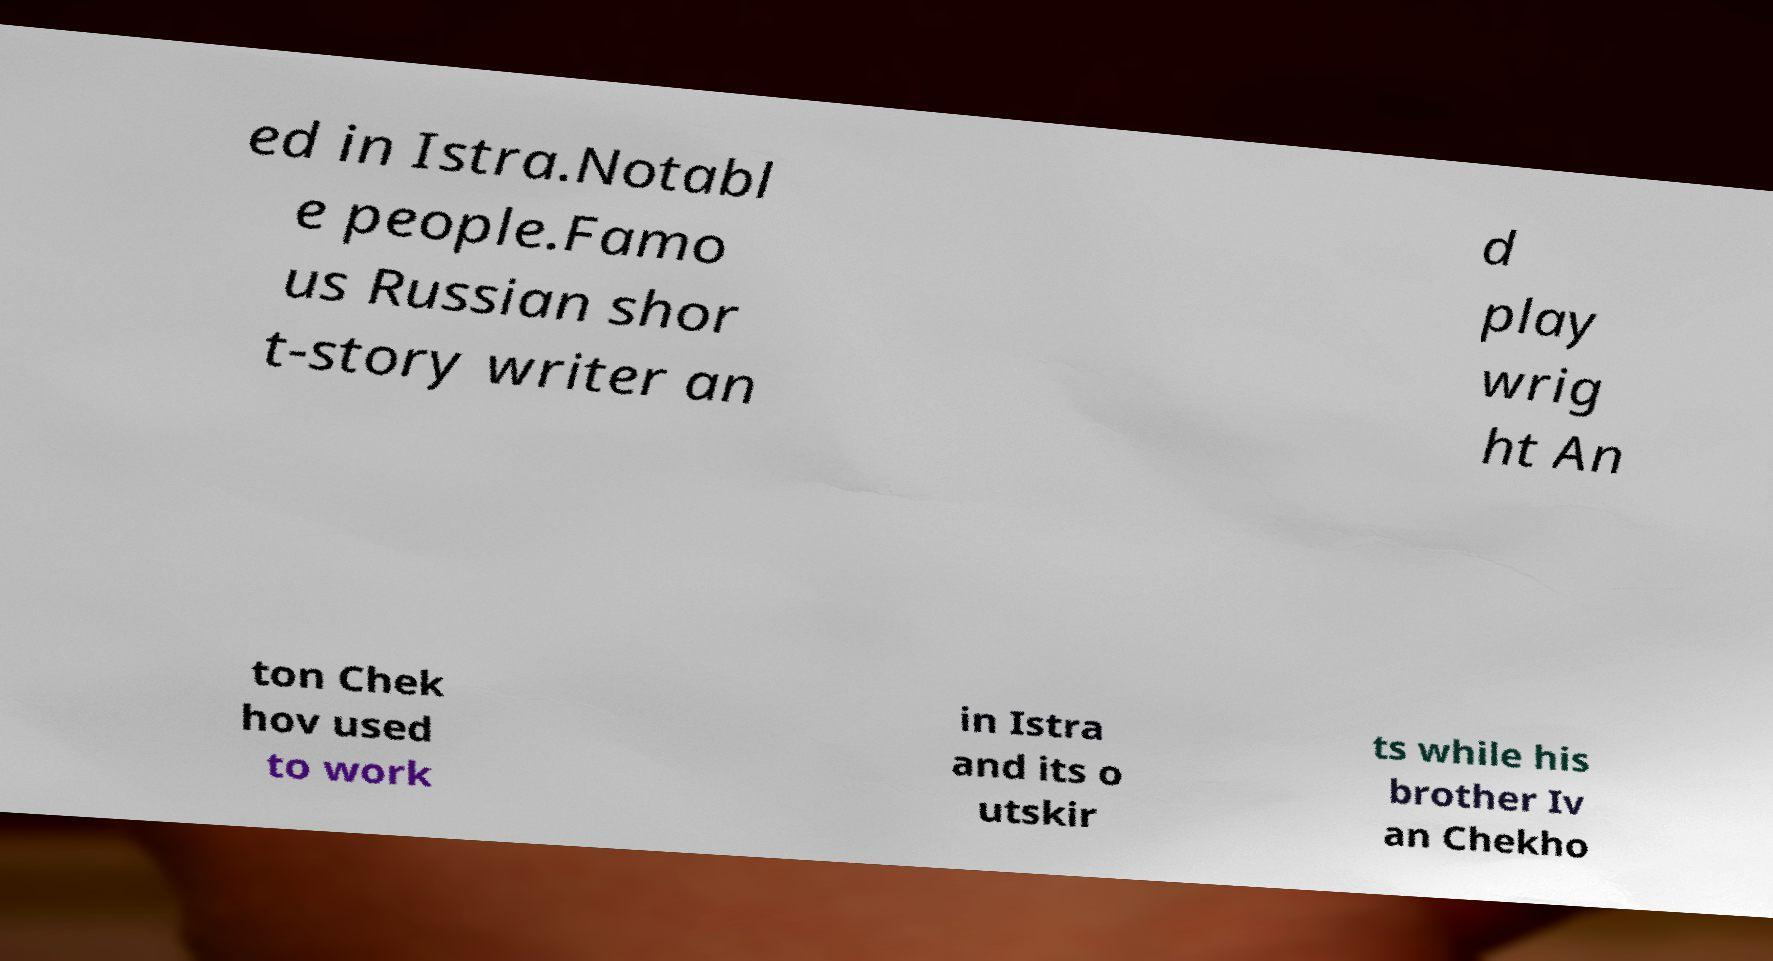There's text embedded in this image that I need extracted. Can you transcribe it verbatim? ed in Istra.Notabl e people.Famo us Russian shor t-story writer an d play wrig ht An ton Chek hov used to work in Istra and its o utskir ts while his brother Iv an Chekho 